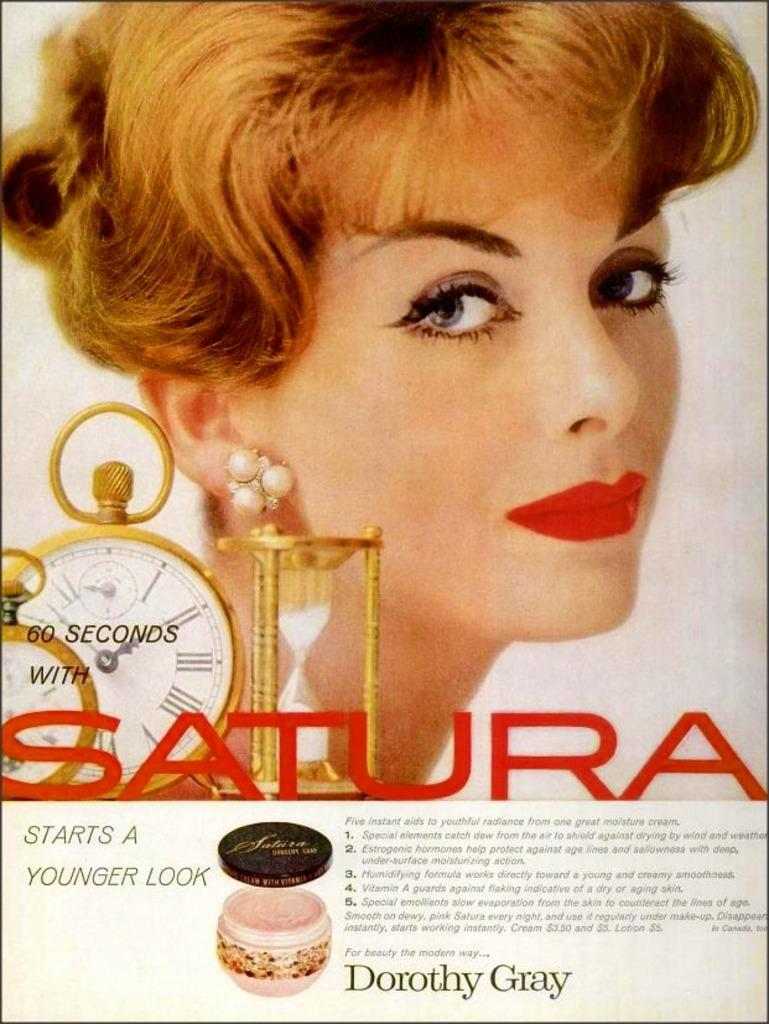<image>
Share a concise interpretation of the image provided. An old poster of a Dorothy Gray facial cream claims it only takes 60 seconds. 